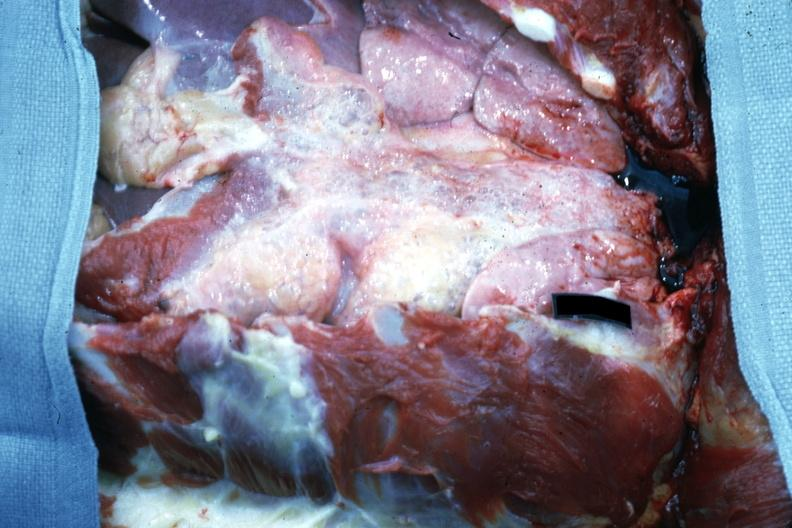what does this image show?
Answer the question using a single word or phrase. Opened chest with breast plate removed easily seen air bubbles 